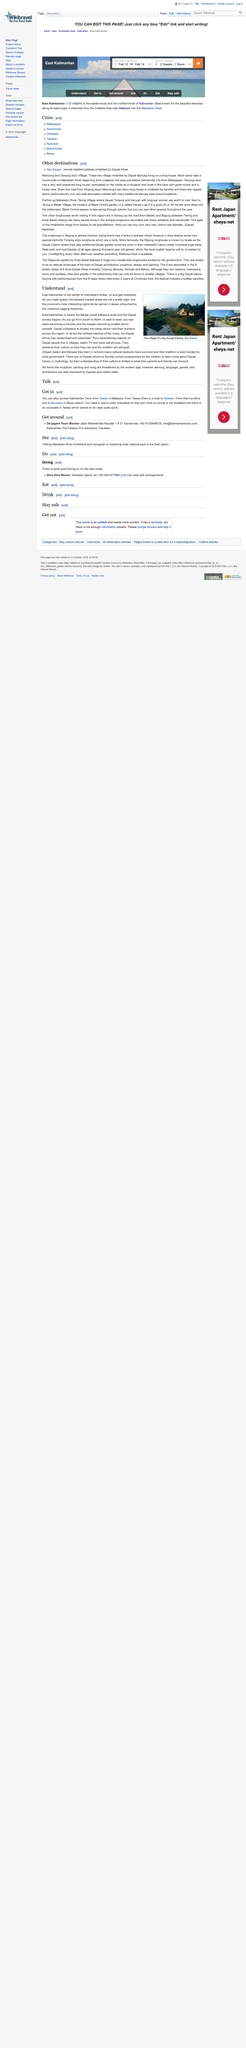Mention a couple of crucial points in this snapshot. In East Kalimantan, the influence of Banjar society comes to an end and Dayak society begins, marking the clear delineation between the two distinct cultures. Apo Kayan is a remote highland plateau inhabited by Dayak tribes, characterized by its stunning natural beauty and rich cultural heritage. East Kalimantan is the primary location for the timber, oil, and gas industries in Indonesia. Mancong and Tanjung Issui are two villages inhabited by the Dayak Bunuaq people, who live in a traditional longhouse. Melak Village is located in close proximity to Tering. 